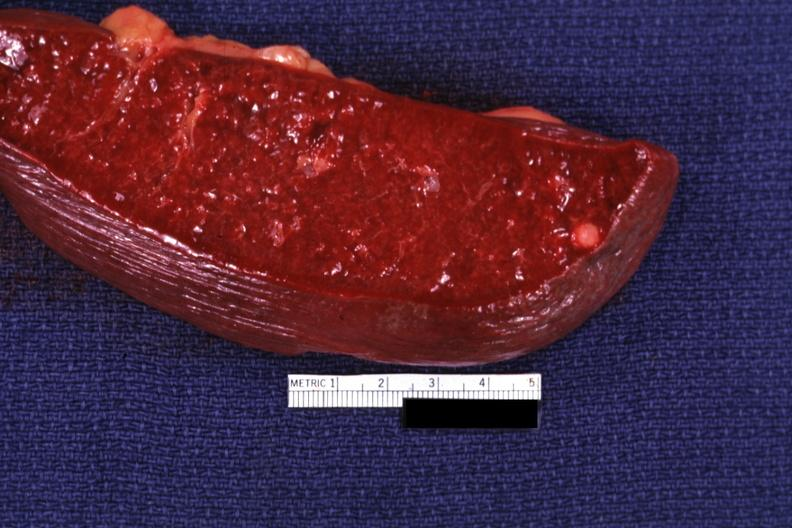does vessel show cut surface with typical healed granuloma?
Answer the question using a single word or phrase. No 